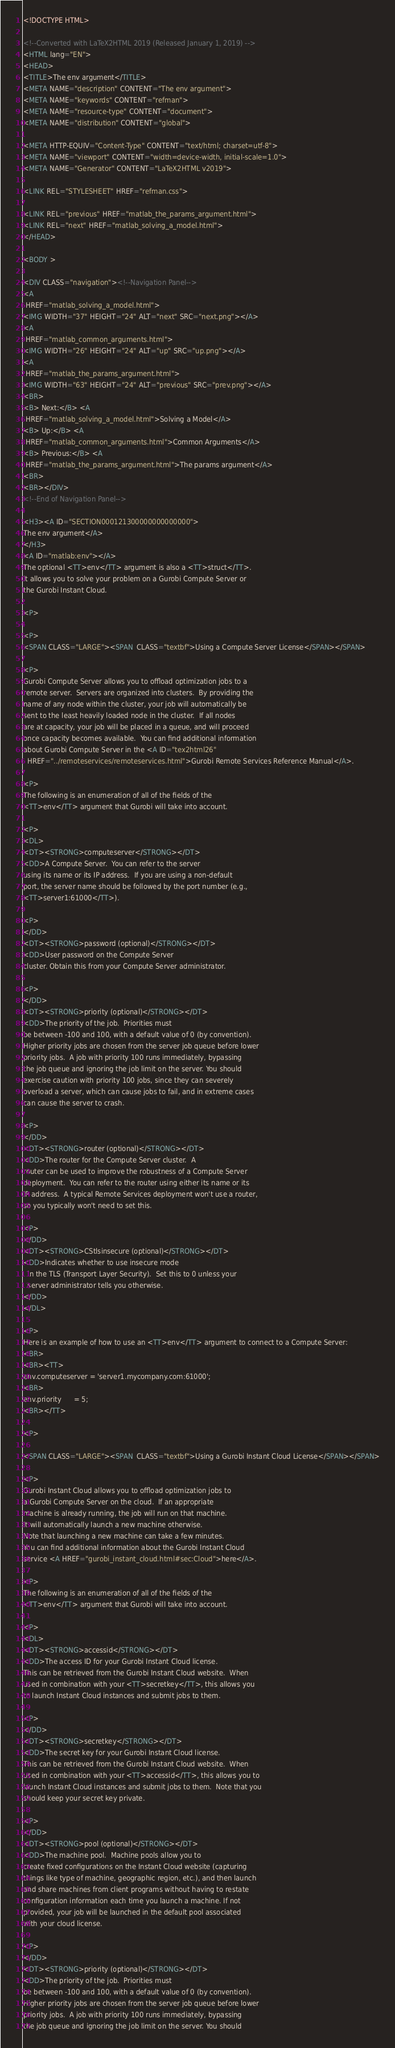<code> <loc_0><loc_0><loc_500><loc_500><_HTML_><!DOCTYPE HTML>

<!--Converted with LaTeX2HTML 2019 (Released January 1, 2019) -->
<HTML lang="EN">
<HEAD>
<TITLE>The env argument</TITLE>
<META NAME="description" CONTENT="The env argument">
<META NAME="keywords" CONTENT="refman">
<META NAME="resource-type" CONTENT="document">
<META NAME="distribution" CONTENT="global">

<META HTTP-EQUIV="Content-Type" CONTENT="text/html; charset=utf-8">
<META NAME="viewport" CONTENT="width=device-width, initial-scale=1.0">
<META NAME="Generator" CONTENT="LaTeX2HTML v2019">

<LINK REL="STYLESHEET" HREF="refman.css">

<LINK REL="previous" HREF="matlab_the_params_argument.html">
<LINK REL="next" HREF="matlab_solving_a_model.html">
</HEAD>

<BODY >

<DIV CLASS="navigation"><!--Navigation Panel-->
<A
 HREF="matlab_solving_a_model.html">
<IMG WIDTH="37" HEIGHT="24" ALT="next" SRC="next.png"></A> 
<A
 HREF="matlab_common_arguments.html">
<IMG WIDTH="26" HEIGHT="24" ALT="up" SRC="up.png"></A> 
<A
 HREF="matlab_the_params_argument.html">
<IMG WIDTH="63" HEIGHT="24" ALT="previous" SRC="prev.png"></A>   
<BR>
<B> Next:</B> <A
 HREF="matlab_solving_a_model.html">Solving a Model</A>
<B> Up:</B> <A
 HREF="matlab_common_arguments.html">Common Arguments</A>
<B> Previous:</B> <A
 HREF="matlab_the_params_argument.html">The params argument</A>
<BR>
<BR></DIV>
<!--End of Navigation Panel-->

<H3><A ID="SECTION000121300000000000000">
The env argument</A>
</H3>
<A ID="matlab:env"></A>
The optional <TT>env</TT> argument is also a <TT>struct</TT>.
It allows you to solve your problem on a Gurobi Compute Server or
the Gurobi Instant Cloud.

<P>

<P>
<SPAN CLASS="LARGE"><SPAN  CLASS="textbf">Using a Compute Server License</SPAN></SPAN>

<P>
Gurobi Compute Server allows you to offload optimization jobs to a
remote server.  Servers are organized into clusters.  By providing the
name of any node within the cluster, your job will automatically be
sent to the least heavily loaded node in the cluster.  If all nodes
are at capacity, your job will be placed in a queue, and will proceed
once capacity becomes available.  You can find additional information
about Gurobi Compute Server in the <A ID="tex2html26"
  HREF="../remoteservices/remoteservices.html">Gurobi Remote Services Reference Manual</A>.

<P>
The following is an enumeration of all of the fields of the
<TT>env</TT> argument that Gurobi will take into account.

<P>
<DL>
<DT><STRONG>computeserver</STRONG></DT>
<DD>A Compute Server.  You can refer to the server
using its name or its IP address.  If you are using a non-default
port, the server name should be followed by the port number (e.g.,
<TT>server1:61000</TT>).

<P>
</DD>
<DT><STRONG>password (optional)</STRONG></DT>
<DD>User password on the Compute Server
cluster. Obtain this from your Compute Server administrator.

<P>
</DD>
<DT><STRONG>priority (optional)</STRONG></DT>
<DD>The priority of the job.  Priorities must
be between -100 and 100, with a default value of 0 (by convention).
Higher priority jobs are chosen from the server job queue before lower
priority jobs.  A job with priority 100 runs immediately, bypassing
the job queue and ignoring the job limit on the server. You should
exercise caution with priority 100 jobs, since they can severely
overload a server, which can cause jobs to fail, and in extreme cases
can cause the server to crash.

<P>
</DD>
<DT><STRONG>router (optional)</STRONG></DT>
<DD>The router for the Compute Server cluster.  A
router can be used to improve the robustness of a Compute Server
deployment.  You can refer to the router using either its name or its
IP address.  A typical Remote Services deployment won't use a router,
so you typically won't need to set this.

<P>
</DD>
<DT><STRONG>CStlsinsecure (optional)</STRONG></DT>
<DD>Indicates whether to use insecure mode
  in the TLS (Transport Layer Security).  Set this to 0 unless your
  server administrator tells you otherwise.
</DD>
</DL>

<P>
Here is an example of how to use an <TT>env</TT> argument to connect to a Compute Server:
<BR>
<BR><TT>
env.computeserver = 'server1.mycompany.com:61000';
<BR>
env.priority      = 5;
<BR></TT>

<P>

<SPAN CLASS="LARGE"><SPAN  CLASS="textbf">Using a Gurobi Instant Cloud License</SPAN></SPAN>

<P>
Gurobi Instant Cloud allows you to offload optimization jobs to
a Gurobi Compute Server on the cloud.  If an appropriate
machine is already running, the job will run on that machine.
It will automatically launch a new machine otherwise.
Note that launching a new machine can take a few minutes.
You can find additional information about the Gurobi Instant Cloud
service <A HREF="gurobi_instant_cloud.html#sec:Cloud">here</A>.

<P>
The following is an enumeration of all of the fields of the
<TT>env</TT> argument that Gurobi will take into account.

<P>
<DL>
<DT><STRONG>accessid</STRONG></DT>
<DD>The access ID for your Gurobi Instant Cloud license.
This can be retrieved from the Gurobi Instant Cloud website.  When
used in combination with your <TT>secretkey</TT>, this allows you
to launch Instant Cloud instances and submit jobs to them.

<P>
</DD>
<DT><STRONG>secretkey</STRONG></DT>
<DD>The secret key for your Gurobi Instant Cloud license.
This can be retrieved from the Gurobi Instant Cloud website.  When
used in combination with your <TT>accessid</TT>, this allows you to
launch Instant Cloud instances and submit jobs to them.  Note that you
should keep your secret key private.

<P>
</DD>
<DT><STRONG>pool (optional)</STRONG></DT>
<DD>The machine pool.  Machine pools allow you to
create fixed configurations on the Instant Cloud website (capturing
things like type of machine, geographic region, etc.), and then launch
and share machines from client programs without having to restate
configuration information each time you launch a machine. If not
provided, your job will be launched in the default pool associated
with your cloud license.

<P>
</DD>
<DT><STRONG>priority (optional)</STRONG></DT>
<DD>The priority of the job.  Priorities must
be between -100 and 100, with a default value of 0 (by convention).
Higher priority jobs are chosen from the server job queue before lower
priority jobs.  A job with priority 100 runs immediately, bypassing
the job queue and ignoring the job limit on the server. You should</code> 